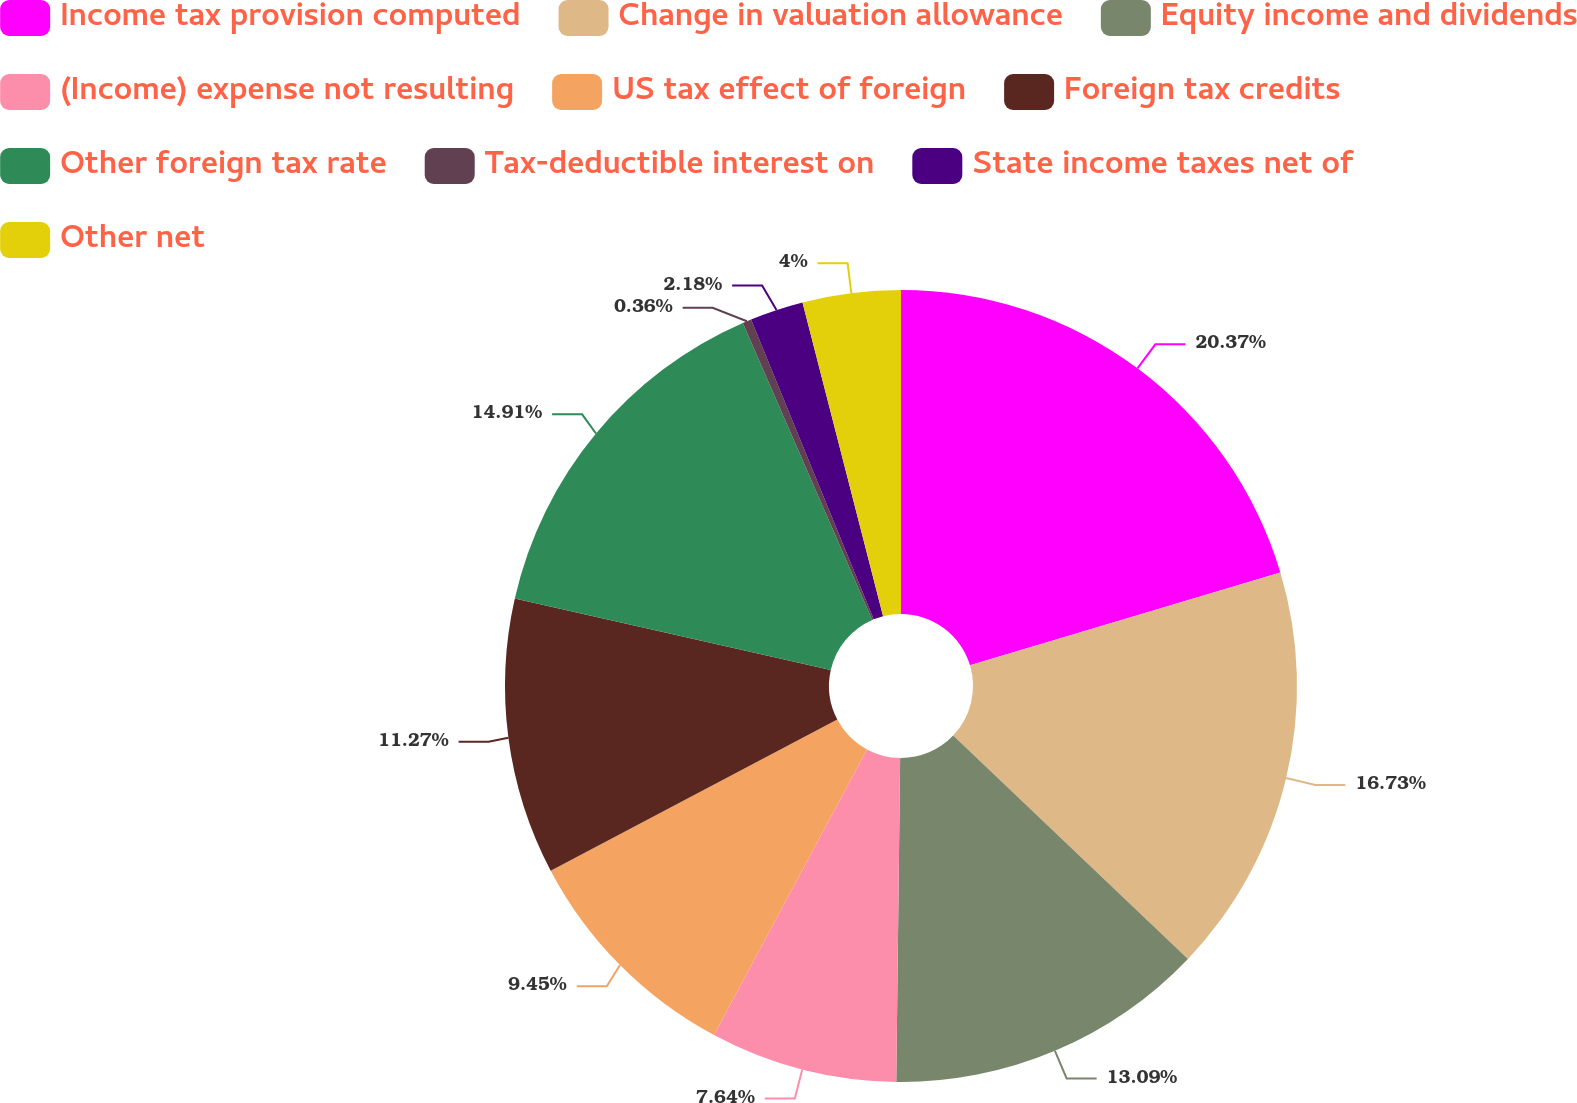<chart> <loc_0><loc_0><loc_500><loc_500><pie_chart><fcel>Income tax provision computed<fcel>Change in valuation allowance<fcel>Equity income and dividends<fcel>(Income) expense not resulting<fcel>US tax effect of foreign<fcel>Foreign tax credits<fcel>Other foreign tax rate<fcel>Tax-deductible interest on<fcel>State income taxes net of<fcel>Other net<nl><fcel>20.37%<fcel>16.73%<fcel>13.09%<fcel>7.64%<fcel>9.45%<fcel>11.27%<fcel>14.91%<fcel>0.36%<fcel>2.18%<fcel>4.0%<nl></chart> 